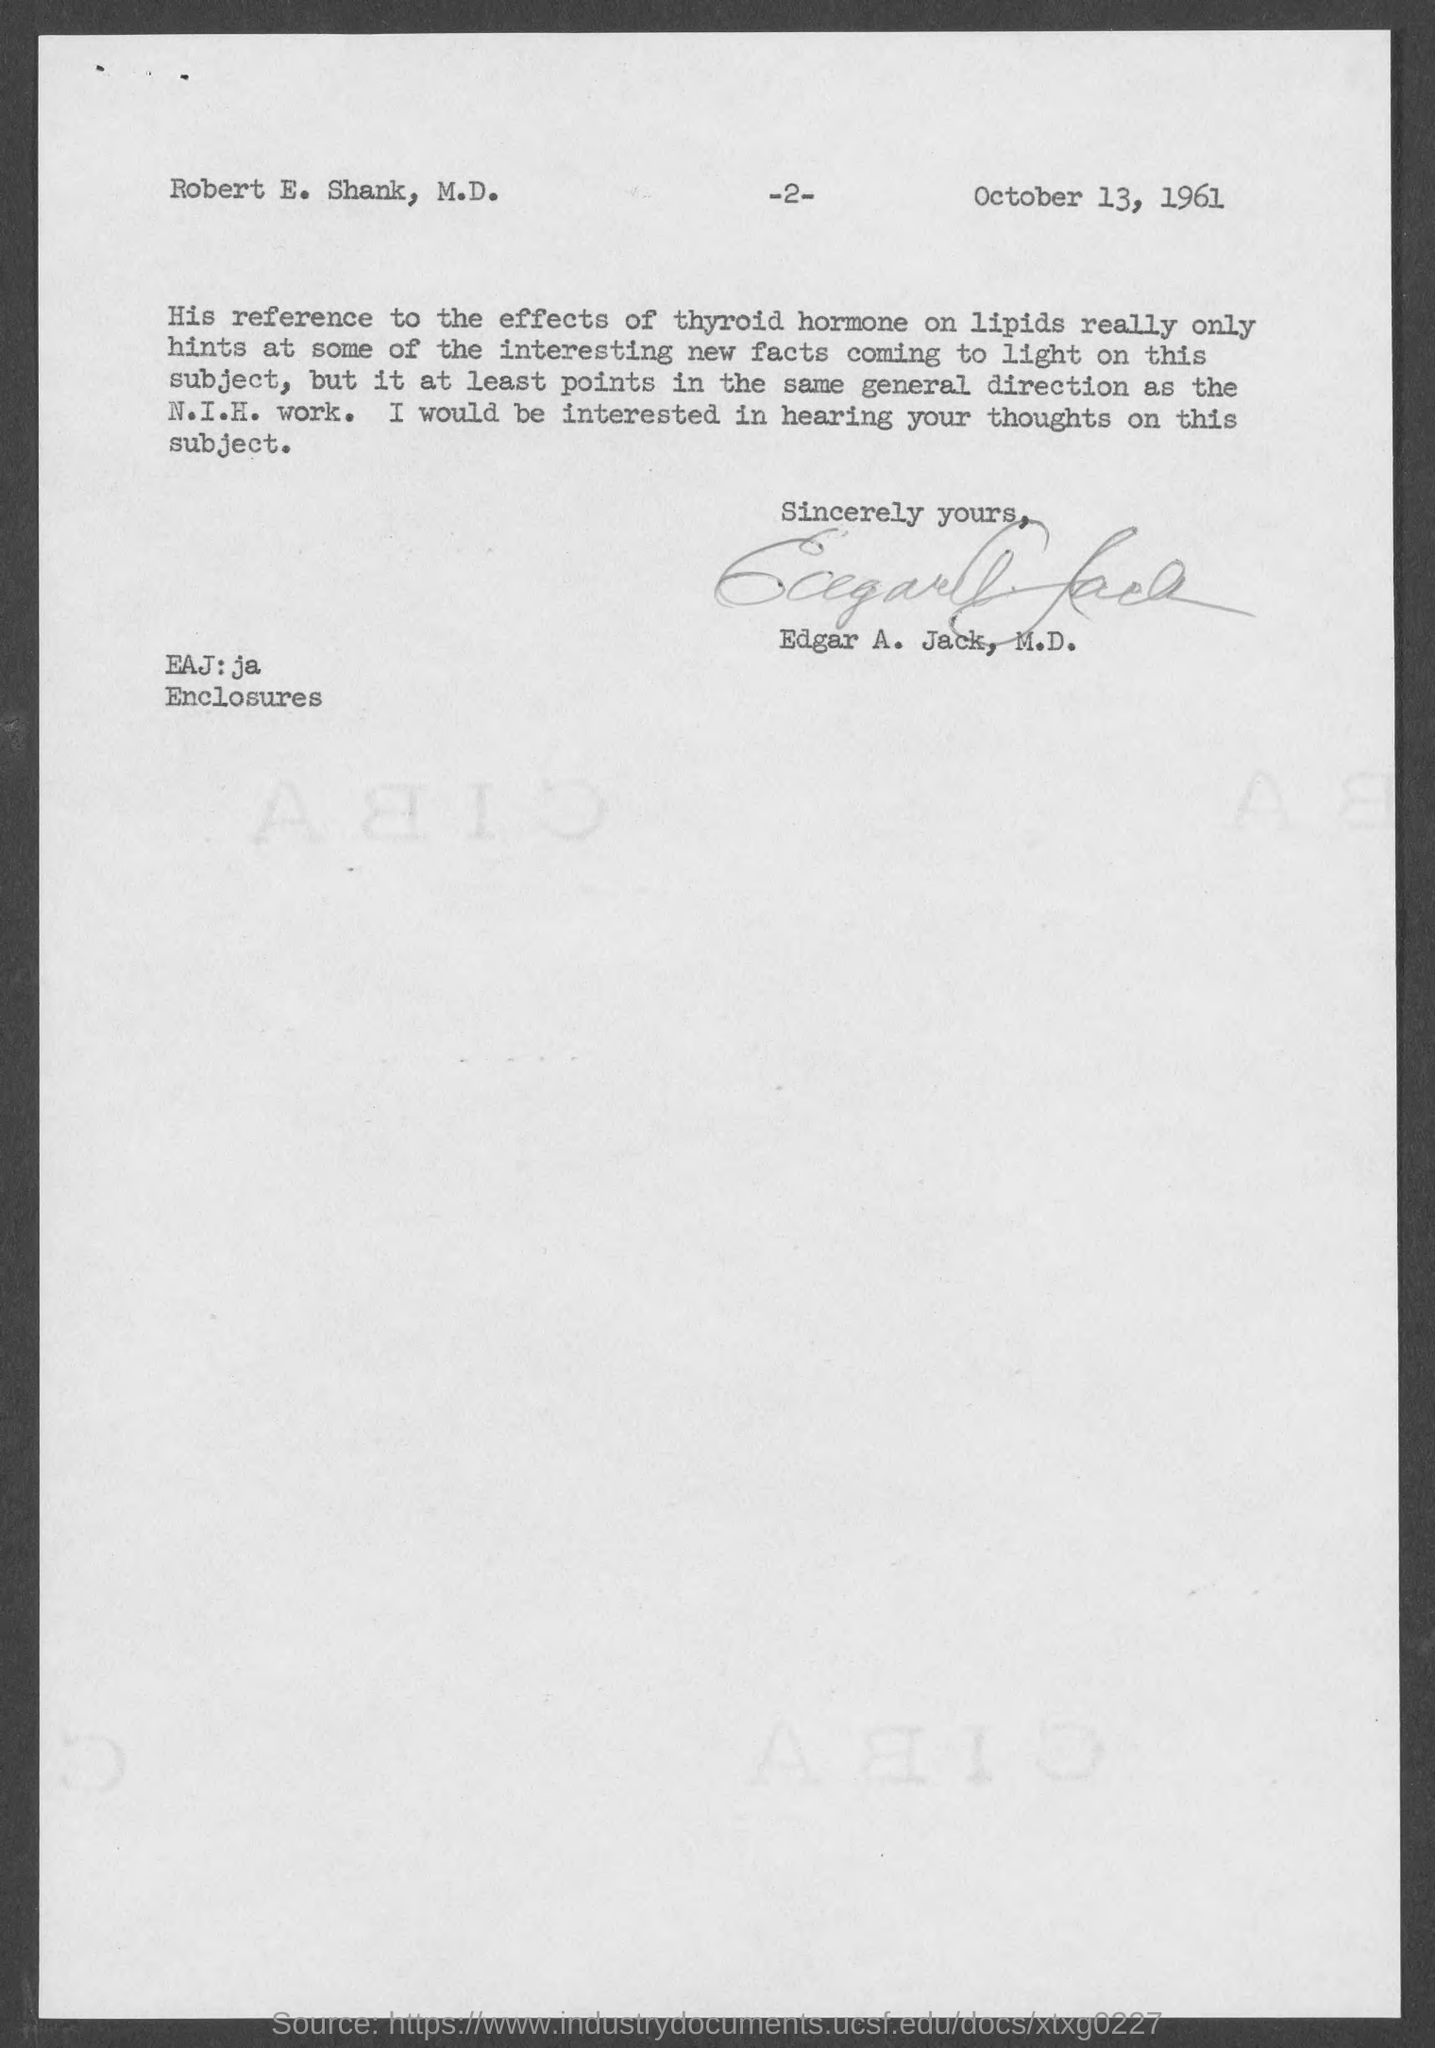What is the page number at top of the page?
Your answer should be compact. 2. What is the date mentioned in document?
Your answer should be compact. October 13, 1961. Who wrote this letter ?
Make the answer very short. Edgar A. Jack, M.D. To whom this letter is written to?
Offer a terse response. Robert e. shank, m.d. 